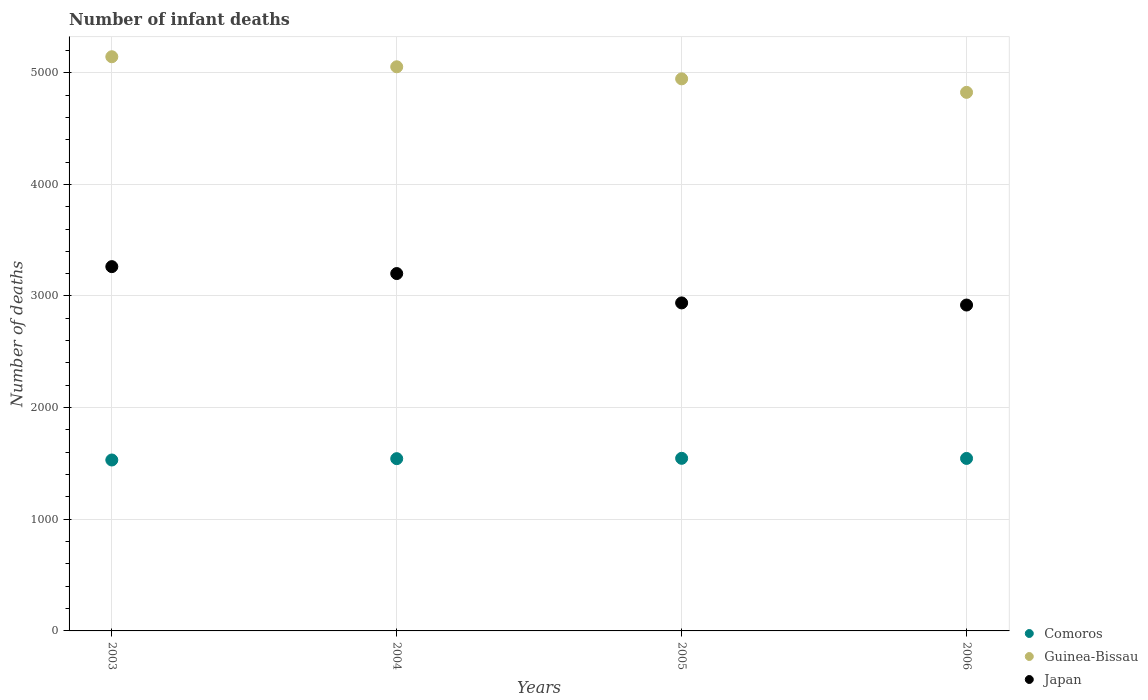How many different coloured dotlines are there?
Give a very brief answer. 3. Is the number of dotlines equal to the number of legend labels?
Your answer should be compact. Yes. What is the number of infant deaths in Comoros in 2004?
Your answer should be compact. 1543. Across all years, what is the maximum number of infant deaths in Guinea-Bissau?
Provide a short and direct response. 5143. Across all years, what is the minimum number of infant deaths in Guinea-Bissau?
Provide a short and direct response. 4824. In which year was the number of infant deaths in Japan minimum?
Your answer should be compact. 2006. What is the total number of infant deaths in Guinea-Bissau in the graph?
Provide a succinct answer. 2.00e+04. What is the difference between the number of infant deaths in Guinea-Bissau in 2003 and that in 2004?
Your answer should be compact. 90. What is the difference between the number of infant deaths in Japan in 2004 and the number of infant deaths in Comoros in 2003?
Your response must be concise. 1670. What is the average number of infant deaths in Comoros per year?
Make the answer very short. 1541.25. In the year 2004, what is the difference between the number of infant deaths in Comoros and number of infant deaths in Guinea-Bissau?
Keep it short and to the point. -3510. What is the ratio of the number of infant deaths in Japan in 2003 to that in 2005?
Ensure brevity in your answer.  1.11. Is the number of infant deaths in Japan in 2003 less than that in 2006?
Give a very brief answer. No. Is the difference between the number of infant deaths in Comoros in 2005 and 2006 greater than the difference between the number of infant deaths in Guinea-Bissau in 2005 and 2006?
Your answer should be compact. No. What is the difference between the highest and the lowest number of infant deaths in Guinea-Bissau?
Offer a terse response. 319. Is the number of infant deaths in Comoros strictly less than the number of infant deaths in Guinea-Bissau over the years?
Ensure brevity in your answer.  Yes. How many dotlines are there?
Your answer should be very brief. 3. Are the values on the major ticks of Y-axis written in scientific E-notation?
Ensure brevity in your answer.  No. Does the graph contain any zero values?
Your response must be concise. No. Does the graph contain grids?
Your answer should be very brief. Yes. How many legend labels are there?
Your response must be concise. 3. How are the legend labels stacked?
Offer a very short reply. Vertical. What is the title of the graph?
Offer a terse response. Number of infant deaths. Does "Philippines" appear as one of the legend labels in the graph?
Ensure brevity in your answer.  No. What is the label or title of the X-axis?
Offer a very short reply. Years. What is the label or title of the Y-axis?
Give a very brief answer. Number of deaths. What is the Number of deaths in Comoros in 2003?
Your response must be concise. 1531. What is the Number of deaths in Guinea-Bissau in 2003?
Provide a short and direct response. 5143. What is the Number of deaths of Japan in 2003?
Make the answer very short. 3263. What is the Number of deaths of Comoros in 2004?
Provide a succinct answer. 1543. What is the Number of deaths in Guinea-Bissau in 2004?
Provide a succinct answer. 5053. What is the Number of deaths of Japan in 2004?
Offer a terse response. 3201. What is the Number of deaths of Comoros in 2005?
Make the answer very short. 1546. What is the Number of deaths of Guinea-Bissau in 2005?
Give a very brief answer. 4945. What is the Number of deaths of Japan in 2005?
Your answer should be very brief. 2938. What is the Number of deaths in Comoros in 2006?
Keep it short and to the point. 1545. What is the Number of deaths of Guinea-Bissau in 2006?
Give a very brief answer. 4824. What is the Number of deaths of Japan in 2006?
Provide a short and direct response. 2919. Across all years, what is the maximum Number of deaths of Comoros?
Your answer should be very brief. 1546. Across all years, what is the maximum Number of deaths of Guinea-Bissau?
Offer a terse response. 5143. Across all years, what is the maximum Number of deaths in Japan?
Give a very brief answer. 3263. Across all years, what is the minimum Number of deaths in Comoros?
Your response must be concise. 1531. Across all years, what is the minimum Number of deaths in Guinea-Bissau?
Offer a terse response. 4824. Across all years, what is the minimum Number of deaths in Japan?
Provide a succinct answer. 2919. What is the total Number of deaths in Comoros in the graph?
Offer a terse response. 6165. What is the total Number of deaths in Guinea-Bissau in the graph?
Offer a terse response. 2.00e+04. What is the total Number of deaths in Japan in the graph?
Offer a very short reply. 1.23e+04. What is the difference between the Number of deaths in Comoros in 2003 and that in 2004?
Ensure brevity in your answer.  -12. What is the difference between the Number of deaths in Guinea-Bissau in 2003 and that in 2004?
Offer a terse response. 90. What is the difference between the Number of deaths of Japan in 2003 and that in 2004?
Your answer should be compact. 62. What is the difference between the Number of deaths of Comoros in 2003 and that in 2005?
Offer a terse response. -15. What is the difference between the Number of deaths in Guinea-Bissau in 2003 and that in 2005?
Make the answer very short. 198. What is the difference between the Number of deaths of Japan in 2003 and that in 2005?
Ensure brevity in your answer.  325. What is the difference between the Number of deaths in Guinea-Bissau in 2003 and that in 2006?
Give a very brief answer. 319. What is the difference between the Number of deaths of Japan in 2003 and that in 2006?
Make the answer very short. 344. What is the difference between the Number of deaths in Guinea-Bissau in 2004 and that in 2005?
Your response must be concise. 108. What is the difference between the Number of deaths of Japan in 2004 and that in 2005?
Your answer should be very brief. 263. What is the difference between the Number of deaths in Comoros in 2004 and that in 2006?
Provide a short and direct response. -2. What is the difference between the Number of deaths of Guinea-Bissau in 2004 and that in 2006?
Offer a terse response. 229. What is the difference between the Number of deaths in Japan in 2004 and that in 2006?
Give a very brief answer. 282. What is the difference between the Number of deaths in Guinea-Bissau in 2005 and that in 2006?
Your answer should be compact. 121. What is the difference between the Number of deaths in Japan in 2005 and that in 2006?
Keep it short and to the point. 19. What is the difference between the Number of deaths of Comoros in 2003 and the Number of deaths of Guinea-Bissau in 2004?
Keep it short and to the point. -3522. What is the difference between the Number of deaths in Comoros in 2003 and the Number of deaths in Japan in 2004?
Offer a very short reply. -1670. What is the difference between the Number of deaths of Guinea-Bissau in 2003 and the Number of deaths of Japan in 2004?
Ensure brevity in your answer.  1942. What is the difference between the Number of deaths of Comoros in 2003 and the Number of deaths of Guinea-Bissau in 2005?
Offer a terse response. -3414. What is the difference between the Number of deaths of Comoros in 2003 and the Number of deaths of Japan in 2005?
Your answer should be compact. -1407. What is the difference between the Number of deaths in Guinea-Bissau in 2003 and the Number of deaths in Japan in 2005?
Make the answer very short. 2205. What is the difference between the Number of deaths in Comoros in 2003 and the Number of deaths in Guinea-Bissau in 2006?
Offer a terse response. -3293. What is the difference between the Number of deaths of Comoros in 2003 and the Number of deaths of Japan in 2006?
Provide a short and direct response. -1388. What is the difference between the Number of deaths of Guinea-Bissau in 2003 and the Number of deaths of Japan in 2006?
Your response must be concise. 2224. What is the difference between the Number of deaths of Comoros in 2004 and the Number of deaths of Guinea-Bissau in 2005?
Your answer should be very brief. -3402. What is the difference between the Number of deaths of Comoros in 2004 and the Number of deaths of Japan in 2005?
Offer a terse response. -1395. What is the difference between the Number of deaths of Guinea-Bissau in 2004 and the Number of deaths of Japan in 2005?
Make the answer very short. 2115. What is the difference between the Number of deaths of Comoros in 2004 and the Number of deaths of Guinea-Bissau in 2006?
Provide a short and direct response. -3281. What is the difference between the Number of deaths in Comoros in 2004 and the Number of deaths in Japan in 2006?
Make the answer very short. -1376. What is the difference between the Number of deaths of Guinea-Bissau in 2004 and the Number of deaths of Japan in 2006?
Give a very brief answer. 2134. What is the difference between the Number of deaths of Comoros in 2005 and the Number of deaths of Guinea-Bissau in 2006?
Ensure brevity in your answer.  -3278. What is the difference between the Number of deaths in Comoros in 2005 and the Number of deaths in Japan in 2006?
Provide a succinct answer. -1373. What is the difference between the Number of deaths of Guinea-Bissau in 2005 and the Number of deaths of Japan in 2006?
Ensure brevity in your answer.  2026. What is the average Number of deaths in Comoros per year?
Keep it short and to the point. 1541.25. What is the average Number of deaths in Guinea-Bissau per year?
Ensure brevity in your answer.  4991.25. What is the average Number of deaths in Japan per year?
Offer a very short reply. 3080.25. In the year 2003, what is the difference between the Number of deaths of Comoros and Number of deaths of Guinea-Bissau?
Ensure brevity in your answer.  -3612. In the year 2003, what is the difference between the Number of deaths in Comoros and Number of deaths in Japan?
Provide a short and direct response. -1732. In the year 2003, what is the difference between the Number of deaths of Guinea-Bissau and Number of deaths of Japan?
Your response must be concise. 1880. In the year 2004, what is the difference between the Number of deaths in Comoros and Number of deaths in Guinea-Bissau?
Your answer should be compact. -3510. In the year 2004, what is the difference between the Number of deaths in Comoros and Number of deaths in Japan?
Give a very brief answer. -1658. In the year 2004, what is the difference between the Number of deaths in Guinea-Bissau and Number of deaths in Japan?
Give a very brief answer. 1852. In the year 2005, what is the difference between the Number of deaths of Comoros and Number of deaths of Guinea-Bissau?
Offer a very short reply. -3399. In the year 2005, what is the difference between the Number of deaths in Comoros and Number of deaths in Japan?
Provide a succinct answer. -1392. In the year 2005, what is the difference between the Number of deaths of Guinea-Bissau and Number of deaths of Japan?
Make the answer very short. 2007. In the year 2006, what is the difference between the Number of deaths of Comoros and Number of deaths of Guinea-Bissau?
Offer a very short reply. -3279. In the year 2006, what is the difference between the Number of deaths of Comoros and Number of deaths of Japan?
Your response must be concise. -1374. In the year 2006, what is the difference between the Number of deaths in Guinea-Bissau and Number of deaths in Japan?
Your response must be concise. 1905. What is the ratio of the Number of deaths in Comoros in 2003 to that in 2004?
Ensure brevity in your answer.  0.99. What is the ratio of the Number of deaths in Guinea-Bissau in 2003 to that in 2004?
Provide a succinct answer. 1.02. What is the ratio of the Number of deaths in Japan in 2003 to that in 2004?
Offer a terse response. 1.02. What is the ratio of the Number of deaths in Comoros in 2003 to that in 2005?
Your answer should be compact. 0.99. What is the ratio of the Number of deaths in Japan in 2003 to that in 2005?
Your answer should be compact. 1.11. What is the ratio of the Number of deaths of Comoros in 2003 to that in 2006?
Provide a short and direct response. 0.99. What is the ratio of the Number of deaths in Guinea-Bissau in 2003 to that in 2006?
Provide a succinct answer. 1.07. What is the ratio of the Number of deaths of Japan in 2003 to that in 2006?
Offer a very short reply. 1.12. What is the ratio of the Number of deaths in Guinea-Bissau in 2004 to that in 2005?
Your response must be concise. 1.02. What is the ratio of the Number of deaths in Japan in 2004 to that in 2005?
Offer a terse response. 1.09. What is the ratio of the Number of deaths of Comoros in 2004 to that in 2006?
Provide a short and direct response. 1. What is the ratio of the Number of deaths in Guinea-Bissau in 2004 to that in 2006?
Provide a short and direct response. 1.05. What is the ratio of the Number of deaths of Japan in 2004 to that in 2006?
Your answer should be very brief. 1.1. What is the ratio of the Number of deaths of Guinea-Bissau in 2005 to that in 2006?
Offer a very short reply. 1.03. What is the difference between the highest and the lowest Number of deaths of Comoros?
Provide a succinct answer. 15. What is the difference between the highest and the lowest Number of deaths of Guinea-Bissau?
Keep it short and to the point. 319. What is the difference between the highest and the lowest Number of deaths in Japan?
Provide a short and direct response. 344. 